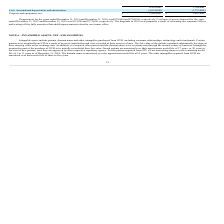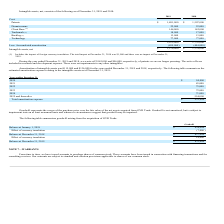From Resonant's financial document, What are the components recorded under cost for intangible assets? The document contains multiple relevant values: Patents, Domain name, Client Base, Trademark, Backlog, Technology. From the document: "Client Base (1) 144,000 142,000 Domain name 22,000 22,000 Intangible assets include patents, domain name and other intangibles purchased from GVR, inc..." Also, What was the impact of foreign currency translation to the cost components in 2019? According to the financial document, No impact. The relevant text states: "act at December 31, 2018 was $1,000 and there was no impact at December 31, 2019...." Also, How many years was the domain name amortized over? Approximate useful life of 10 years. The document states: "r 31, 2019. The domain name is amortized over the approximate useful life of 10 years. The other intangibles acquired from GVR are amortized over thei..." Additionally, Which year was the cost for patents lower? According to the financial document, 2018. The relevant text states: "he years ended December 31, 2019 and December 31, 2018 was $870,000 and $704,000, respectively. Cost basis of assets disposed for the years..." Also, can you calculate: What was the change in total cost? Based on the calculation: 2,075,000 - 1,778,000 , the result is 297000. This is based on the information: "2,075,000 1,778,000 2,075,000 1,778,000..." The key data points involved are: 1,778,000, 2,075,000. Also, can you calculate: What was the percentage change in net intangible assets? To answer this question, I need to perform calculations using the financial data. The calculation is: ($1,576,000 - $ 1,374,000)/$ 1,374,000 , which equals 14.7 (percentage). This is based on the information: "Intangible assets, net $ 1,576,000 $ 1,374,000 Intangible assets, net $ 1,576,000 $ 1,374,000..." The key data points involved are: 1,374,000, 1,576,000. 